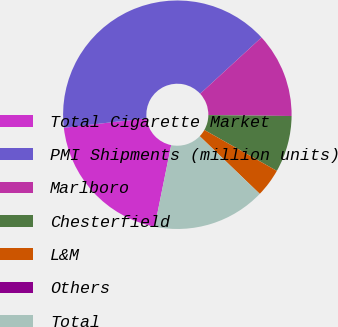Convert chart to OTSL. <chart><loc_0><loc_0><loc_500><loc_500><pie_chart><fcel>Total Cigarette Market<fcel>PMI Shipments (million units)<fcel>Marlboro<fcel>Chesterfield<fcel>L&M<fcel>Others<fcel>Total<nl><fcel>20.0%<fcel>40.0%<fcel>12.0%<fcel>8.0%<fcel>4.0%<fcel>0.0%<fcel>16.0%<nl></chart> 